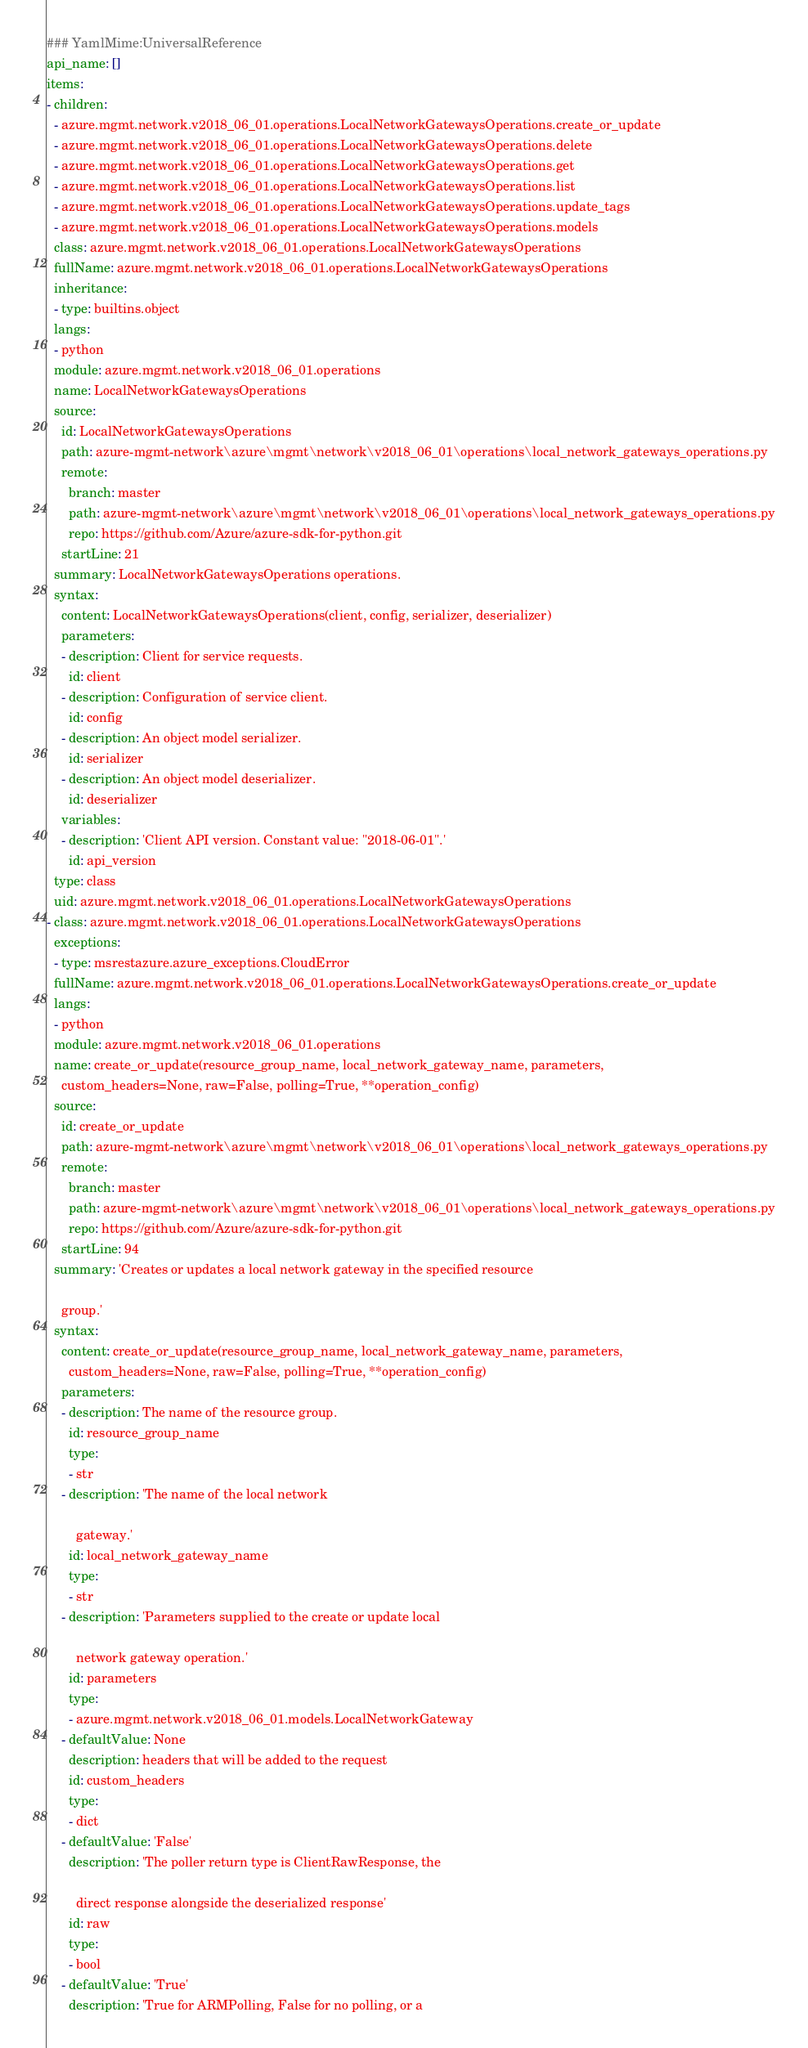<code> <loc_0><loc_0><loc_500><loc_500><_YAML_>### YamlMime:UniversalReference
api_name: []
items:
- children:
  - azure.mgmt.network.v2018_06_01.operations.LocalNetworkGatewaysOperations.create_or_update
  - azure.mgmt.network.v2018_06_01.operations.LocalNetworkGatewaysOperations.delete
  - azure.mgmt.network.v2018_06_01.operations.LocalNetworkGatewaysOperations.get
  - azure.mgmt.network.v2018_06_01.operations.LocalNetworkGatewaysOperations.list
  - azure.mgmt.network.v2018_06_01.operations.LocalNetworkGatewaysOperations.update_tags
  - azure.mgmt.network.v2018_06_01.operations.LocalNetworkGatewaysOperations.models
  class: azure.mgmt.network.v2018_06_01.operations.LocalNetworkGatewaysOperations
  fullName: azure.mgmt.network.v2018_06_01.operations.LocalNetworkGatewaysOperations
  inheritance:
  - type: builtins.object
  langs:
  - python
  module: azure.mgmt.network.v2018_06_01.operations
  name: LocalNetworkGatewaysOperations
  source:
    id: LocalNetworkGatewaysOperations
    path: azure-mgmt-network\azure\mgmt\network\v2018_06_01\operations\local_network_gateways_operations.py
    remote:
      branch: master
      path: azure-mgmt-network\azure\mgmt\network\v2018_06_01\operations\local_network_gateways_operations.py
      repo: https://github.com/Azure/azure-sdk-for-python.git
    startLine: 21
  summary: LocalNetworkGatewaysOperations operations.
  syntax:
    content: LocalNetworkGatewaysOperations(client, config, serializer, deserializer)
    parameters:
    - description: Client for service requests.
      id: client
    - description: Configuration of service client.
      id: config
    - description: An object model serializer.
      id: serializer
    - description: An object model deserializer.
      id: deserializer
    variables:
    - description: 'Client API version. Constant value: "2018-06-01".'
      id: api_version
  type: class
  uid: azure.mgmt.network.v2018_06_01.operations.LocalNetworkGatewaysOperations
- class: azure.mgmt.network.v2018_06_01.operations.LocalNetworkGatewaysOperations
  exceptions:
  - type: msrestazure.azure_exceptions.CloudError
  fullName: azure.mgmt.network.v2018_06_01.operations.LocalNetworkGatewaysOperations.create_or_update
  langs:
  - python
  module: azure.mgmt.network.v2018_06_01.operations
  name: create_or_update(resource_group_name, local_network_gateway_name, parameters,
    custom_headers=None, raw=False, polling=True, **operation_config)
  source:
    id: create_or_update
    path: azure-mgmt-network\azure\mgmt\network\v2018_06_01\operations\local_network_gateways_operations.py
    remote:
      branch: master
      path: azure-mgmt-network\azure\mgmt\network\v2018_06_01\operations\local_network_gateways_operations.py
      repo: https://github.com/Azure/azure-sdk-for-python.git
    startLine: 94
  summary: 'Creates or updates a local network gateway in the specified resource

    group.'
  syntax:
    content: create_or_update(resource_group_name, local_network_gateway_name, parameters,
      custom_headers=None, raw=False, polling=True, **operation_config)
    parameters:
    - description: The name of the resource group.
      id: resource_group_name
      type:
      - str
    - description: 'The name of the local network

        gateway.'
      id: local_network_gateway_name
      type:
      - str
    - description: 'Parameters supplied to the create or update local

        network gateway operation.'
      id: parameters
      type:
      - azure.mgmt.network.v2018_06_01.models.LocalNetworkGateway
    - defaultValue: None
      description: headers that will be added to the request
      id: custom_headers
      type:
      - dict
    - defaultValue: 'False'
      description: 'The poller return type is ClientRawResponse, the

        direct response alongside the deserialized response'
      id: raw
      type:
      - bool
    - defaultValue: 'True'
      description: 'True for ARMPolling, False for no polling, or a
</code> 